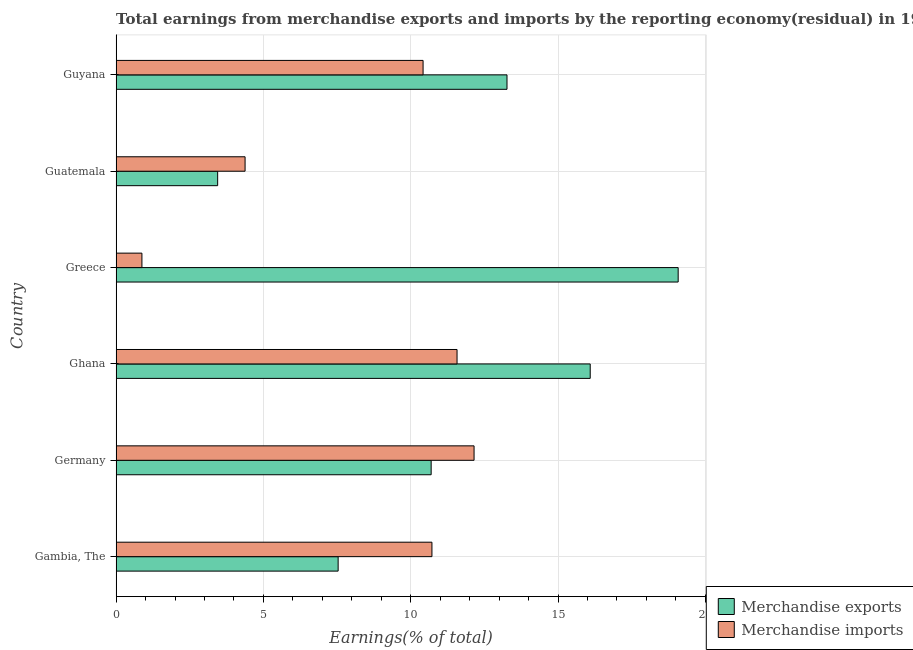How many groups of bars are there?
Provide a short and direct response. 6. Are the number of bars per tick equal to the number of legend labels?
Your answer should be very brief. Yes. How many bars are there on the 5th tick from the bottom?
Provide a succinct answer. 2. What is the label of the 3rd group of bars from the top?
Give a very brief answer. Greece. What is the earnings from merchandise imports in Guyana?
Give a very brief answer. 10.42. Across all countries, what is the maximum earnings from merchandise imports?
Your answer should be very brief. 12.15. Across all countries, what is the minimum earnings from merchandise imports?
Provide a short and direct response. 0.88. In which country was the earnings from merchandise exports maximum?
Make the answer very short. Greece. In which country was the earnings from merchandise imports minimum?
Ensure brevity in your answer.  Greece. What is the total earnings from merchandise exports in the graph?
Ensure brevity in your answer.  70.12. What is the difference between the earnings from merchandise imports in Gambia, The and the earnings from merchandise exports in Ghana?
Keep it short and to the point. -5.37. What is the average earnings from merchandise exports per country?
Ensure brevity in your answer.  11.69. What is the difference between the earnings from merchandise exports and earnings from merchandise imports in Guyana?
Provide a succinct answer. 2.85. In how many countries, is the earnings from merchandise exports greater than 10 %?
Offer a terse response. 4. What is the ratio of the earnings from merchandise exports in Gambia, The to that in Ghana?
Provide a short and direct response. 0.47. Is the difference between the earnings from merchandise exports in Ghana and Guatemala greater than the difference between the earnings from merchandise imports in Ghana and Guatemala?
Provide a succinct answer. Yes. What is the difference between the highest and the second highest earnings from merchandise exports?
Your response must be concise. 2.98. What is the difference between the highest and the lowest earnings from merchandise exports?
Provide a succinct answer. 15.63. What does the 2nd bar from the top in Greece represents?
Ensure brevity in your answer.  Merchandise exports. What does the 1st bar from the bottom in Greece represents?
Offer a very short reply. Merchandise exports. How many bars are there?
Offer a very short reply. 12. Are the values on the major ticks of X-axis written in scientific E-notation?
Ensure brevity in your answer.  No. Does the graph contain any zero values?
Your response must be concise. No. Does the graph contain grids?
Your answer should be compact. Yes. How are the legend labels stacked?
Provide a short and direct response. Vertical. What is the title of the graph?
Provide a succinct answer. Total earnings from merchandise exports and imports by the reporting economy(residual) in 1967. Does "Total Population" appear as one of the legend labels in the graph?
Ensure brevity in your answer.  No. What is the label or title of the X-axis?
Your answer should be very brief. Earnings(% of total). What is the Earnings(% of total) in Merchandise exports in Gambia, The?
Keep it short and to the point. 7.54. What is the Earnings(% of total) of Merchandise imports in Gambia, The?
Keep it short and to the point. 10.72. What is the Earnings(% of total) in Merchandise exports in Germany?
Your answer should be very brief. 10.69. What is the Earnings(% of total) in Merchandise imports in Germany?
Make the answer very short. 12.15. What is the Earnings(% of total) of Merchandise exports in Ghana?
Your response must be concise. 16.09. What is the Earnings(% of total) in Merchandise imports in Ghana?
Offer a very short reply. 11.57. What is the Earnings(% of total) in Merchandise exports in Greece?
Provide a short and direct response. 19.08. What is the Earnings(% of total) of Merchandise imports in Greece?
Provide a short and direct response. 0.88. What is the Earnings(% of total) in Merchandise exports in Guatemala?
Provide a succinct answer. 3.45. What is the Earnings(% of total) of Merchandise imports in Guatemala?
Provide a short and direct response. 4.38. What is the Earnings(% of total) in Merchandise exports in Guyana?
Your answer should be compact. 13.27. What is the Earnings(% of total) in Merchandise imports in Guyana?
Give a very brief answer. 10.42. Across all countries, what is the maximum Earnings(% of total) of Merchandise exports?
Your response must be concise. 19.08. Across all countries, what is the maximum Earnings(% of total) of Merchandise imports?
Your answer should be very brief. 12.15. Across all countries, what is the minimum Earnings(% of total) in Merchandise exports?
Make the answer very short. 3.45. Across all countries, what is the minimum Earnings(% of total) of Merchandise imports?
Provide a succinct answer. 0.88. What is the total Earnings(% of total) in Merchandise exports in the graph?
Keep it short and to the point. 70.12. What is the total Earnings(% of total) of Merchandise imports in the graph?
Offer a very short reply. 50.11. What is the difference between the Earnings(% of total) in Merchandise exports in Gambia, The and that in Germany?
Keep it short and to the point. -3.16. What is the difference between the Earnings(% of total) in Merchandise imports in Gambia, The and that in Germany?
Provide a succinct answer. -1.43. What is the difference between the Earnings(% of total) of Merchandise exports in Gambia, The and that in Ghana?
Keep it short and to the point. -8.56. What is the difference between the Earnings(% of total) of Merchandise imports in Gambia, The and that in Ghana?
Your answer should be compact. -0.85. What is the difference between the Earnings(% of total) in Merchandise exports in Gambia, The and that in Greece?
Provide a short and direct response. -11.54. What is the difference between the Earnings(% of total) of Merchandise imports in Gambia, The and that in Greece?
Give a very brief answer. 9.84. What is the difference between the Earnings(% of total) in Merchandise exports in Gambia, The and that in Guatemala?
Offer a terse response. 4.09. What is the difference between the Earnings(% of total) of Merchandise imports in Gambia, The and that in Guatemala?
Your answer should be very brief. 6.34. What is the difference between the Earnings(% of total) of Merchandise exports in Gambia, The and that in Guyana?
Give a very brief answer. -5.73. What is the difference between the Earnings(% of total) of Merchandise imports in Gambia, The and that in Guyana?
Provide a succinct answer. 0.3. What is the difference between the Earnings(% of total) in Merchandise exports in Germany and that in Ghana?
Your answer should be very brief. -5.4. What is the difference between the Earnings(% of total) of Merchandise imports in Germany and that in Ghana?
Ensure brevity in your answer.  0.58. What is the difference between the Earnings(% of total) in Merchandise exports in Germany and that in Greece?
Give a very brief answer. -8.39. What is the difference between the Earnings(% of total) of Merchandise imports in Germany and that in Greece?
Offer a very short reply. 11.27. What is the difference between the Earnings(% of total) in Merchandise exports in Germany and that in Guatemala?
Provide a succinct answer. 7.25. What is the difference between the Earnings(% of total) in Merchandise imports in Germany and that in Guatemala?
Provide a succinct answer. 7.77. What is the difference between the Earnings(% of total) in Merchandise exports in Germany and that in Guyana?
Provide a succinct answer. -2.57. What is the difference between the Earnings(% of total) of Merchandise imports in Germany and that in Guyana?
Give a very brief answer. 1.73. What is the difference between the Earnings(% of total) in Merchandise exports in Ghana and that in Greece?
Make the answer very short. -2.99. What is the difference between the Earnings(% of total) of Merchandise imports in Ghana and that in Greece?
Your answer should be very brief. 10.7. What is the difference between the Earnings(% of total) of Merchandise exports in Ghana and that in Guatemala?
Offer a terse response. 12.65. What is the difference between the Earnings(% of total) of Merchandise imports in Ghana and that in Guatemala?
Your response must be concise. 7.19. What is the difference between the Earnings(% of total) in Merchandise exports in Ghana and that in Guyana?
Offer a very short reply. 2.83. What is the difference between the Earnings(% of total) in Merchandise imports in Ghana and that in Guyana?
Offer a terse response. 1.15. What is the difference between the Earnings(% of total) in Merchandise exports in Greece and that in Guatemala?
Your response must be concise. 15.63. What is the difference between the Earnings(% of total) in Merchandise imports in Greece and that in Guatemala?
Keep it short and to the point. -3.5. What is the difference between the Earnings(% of total) in Merchandise exports in Greece and that in Guyana?
Offer a terse response. 5.81. What is the difference between the Earnings(% of total) in Merchandise imports in Greece and that in Guyana?
Provide a succinct answer. -9.54. What is the difference between the Earnings(% of total) in Merchandise exports in Guatemala and that in Guyana?
Make the answer very short. -9.82. What is the difference between the Earnings(% of total) of Merchandise imports in Guatemala and that in Guyana?
Make the answer very short. -6.04. What is the difference between the Earnings(% of total) of Merchandise exports in Gambia, The and the Earnings(% of total) of Merchandise imports in Germany?
Your response must be concise. -4.61. What is the difference between the Earnings(% of total) in Merchandise exports in Gambia, The and the Earnings(% of total) in Merchandise imports in Ghana?
Your answer should be compact. -4.04. What is the difference between the Earnings(% of total) of Merchandise exports in Gambia, The and the Earnings(% of total) of Merchandise imports in Greece?
Ensure brevity in your answer.  6.66. What is the difference between the Earnings(% of total) in Merchandise exports in Gambia, The and the Earnings(% of total) in Merchandise imports in Guatemala?
Make the answer very short. 3.16. What is the difference between the Earnings(% of total) in Merchandise exports in Gambia, The and the Earnings(% of total) in Merchandise imports in Guyana?
Provide a short and direct response. -2.88. What is the difference between the Earnings(% of total) in Merchandise exports in Germany and the Earnings(% of total) in Merchandise imports in Ghana?
Provide a short and direct response. -0.88. What is the difference between the Earnings(% of total) in Merchandise exports in Germany and the Earnings(% of total) in Merchandise imports in Greece?
Make the answer very short. 9.82. What is the difference between the Earnings(% of total) in Merchandise exports in Germany and the Earnings(% of total) in Merchandise imports in Guatemala?
Give a very brief answer. 6.32. What is the difference between the Earnings(% of total) in Merchandise exports in Germany and the Earnings(% of total) in Merchandise imports in Guyana?
Offer a very short reply. 0.27. What is the difference between the Earnings(% of total) of Merchandise exports in Ghana and the Earnings(% of total) of Merchandise imports in Greece?
Offer a very short reply. 15.22. What is the difference between the Earnings(% of total) of Merchandise exports in Ghana and the Earnings(% of total) of Merchandise imports in Guatemala?
Your response must be concise. 11.72. What is the difference between the Earnings(% of total) of Merchandise exports in Ghana and the Earnings(% of total) of Merchandise imports in Guyana?
Make the answer very short. 5.67. What is the difference between the Earnings(% of total) of Merchandise exports in Greece and the Earnings(% of total) of Merchandise imports in Guatemala?
Give a very brief answer. 14.7. What is the difference between the Earnings(% of total) of Merchandise exports in Greece and the Earnings(% of total) of Merchandise imports in Guyana?
Your answer should be compact. 8.66. What is the difference between the Earnings(% of total) in Merchandise exports in Guatemala and the Earnings(% of total) in Merchandise imports in Guyana?
Give a very brief answer. -6.97. What is the average Earnings(% of total) in Merchandise exports per country?
Provide a short and direct response. 11.69. What is the average Earnings(% of total) in Merchandise imports per country?
Your response must be concise. 8.35. What is the difference between the Earnings(% of total) in Merchandise exports and Earnings(% of total) in Merchandise imports in Gambia, The?
Offer a very short reply. -3.18. What is the difference between the Earnings(% of total) of Merchandise exports and Earnings(% of total) of Merchandise imports in Germany?
Provide a succinct answer. -1.46. What is the difference between the Earnings(% of total) in Merchandise exports and Earnings(% of total) in Merchandise imports in Ghana?
Offer a terse response. 4.52. What is the difference between the Earnings(% of total) in Merchandise exports and Earnings(% of total) in Merchandise imports in Greece?
Keep it short and to the point. 18.2. What is the difference between the Earnings(% of total) in Merchandise exports and Earnings(% of total) in Merchandise imports in Guatemala?
Make the answer very short. -0.93. What is the difference between the Earnings(% of total) of Merchandise exports and Earnings(% of total) of Merchandise imports in Guyana?
Provide a short and direct response. 2.85. What is the ratio of the Earnings(% of total) in Merchandise exports in Gambia, The to that in Germany?
Provide a short and direct response. 0.7. What is the ratio of the Earnings(% of total) of Merchandise imports in Gambia, The to that in Germany?
Your answer should be very brief. 0.88. What is the ratio of the Earnings(% of total) of Merchandise exports in Gambia, The to that in Ghana?
Your answer should be compact. 0.47. What is the ratio of the Earnings(% of total) of Merchandise imports in Gambia, The to that in Ghana?
Provide a short and direct response. 0.93. What is the ratio of the Earnings(% of total) of Merchandise exports in Gambia, The to that in Greece?
Give a very brief answer. 0.4. What is the ratio of the Earnings(% of total) in Merchandise imports in Gambia, The to that in Greece?
Ensure brevity in your answer.  12.25. What is the ratio of the Earnings(% of total) of Merchandise exports in Gambia, The to that in Guatemala?
Offer a terse response. 2.19. What is the ratio of the Earnings(% of total) of Merchandise imports in Gambia, The to that in Guatemala?
Provide a succinct answer. 2.45. What is the ratio of the Earnings(% of total) of Merchandise exports in Gambia, The to that in Guyana?
Give a very brief answer. 0.57. What is the ratio of the Earnings(% of total) of Merchandise imports in Gambia, The to that in Guyana?
Your answer should be compact. 1.03. What is the ratio of the Earnings(% of total) in Merchandise exports in Germany to that in Ghana?
Your answer should be compact. 0.66. What is the ratio of the Earnings(% of total) of Merchandise imports in Germany to that in Ghana?
Provide a succinct answer. 1.05. What is the ratio of the Earnings(% of total) of Merchandise exports in Germany to that in Greece?
Ensure brevity in your answer.  0.56. What is the ratio of the Earnings(% of total) in Merchandise imports in Germany to that in Greece?
Your answer should be compact. 13.88. What is the ratio of the Earnings(% of total) of Merchandise exports in Germany to that in Guatemala?
Your answer should be very brief. 3.1. What is the ratio of the Earnings(% of total) in Merchandise imports in Germany to that in Guatemala?
Ensure brevity in your answer.  2.78. What is the ratio of the Earnings(% of total) of Merchandise exports in Germany to that in Guyana?
Provide a short and direct response. 0.81. What is the ratio of the Earnings(% of total) in Merchandise imports in Germany to that in Guyana?
Offer a terse response. 1.17. What is the ratio of the Earnings(% of total) of Merchandise exports in Ghana to that in Greece?
Your answer should be compact. 0.84. What is the ratio of the Earnings(% of total) of Merchandise imports in Ghana to that in Greece?
Keep it short and to the point. 13.22. What is the ratio of the Earnings(% of total) of Merchandise exports in Ghana to that in Guatemala?
Your answer should be compact. 4.67. What is the ratio of the Earnings(% of total) in Merchandise imports in Ghana to that in Guatemala?
Your response must be concise. 2.64. What is the ratio of the Earnings(% of total) in Merchandise exports in Ghana to that in Guyana?
Provide a succinct answer. 1.21. What is the ratio of the Earnings(% of total) in Merchandise imports in Ghana to that in Guyana?
Ensure brevity in your answer.  1.11. What is the ratio of the Earnings(% of total) of Merchandise exports in Greece to that in Guatemala?
Provide a succinct answer. 5.54. What is the ratio of the Earnings(% of total) of Merchandise exports in Greece to that in Guyana?
Offer a very short reply. 1.44. What is the ratio of the Earnings(% of total) of Merchandise imports in Greece to that in Guyana?
Offer a very short reply. 0.08. What is the ratio of the Earnings(% of total) of Merchandise exports in Guatemala to that in Guyana?
Offer a very short reply. 0.26. What is the ratio of the Earnings(% of total) of Merchandise imports in Guatemala to that in Guyana?
Keep it short and to the point. 0.42. What is the difference between the highest and the second highest Earnings(% of total) of Merchandise exports?
Offer a terse response. 2.99. What is the difference between the highest and the second highest Earnings(% of total) of Merchandise imports?
Give a very brief answer. 0.58. What is the difference between the highest and the lowest Earnings(% of total) in Merchandise exports?
Your answer should be compact. 15.63. What is the difference between the highest and the lowest Earnings(% of total) of Merchandise imports?
Offer a terse response. 11.27. 